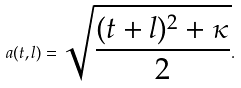<formula> <loc_0><loc_0><loc_500><loc_500>a ( t , l ) = \sqrt { \frac { ( t + l ) ^ { 2 } + \kappa } { 2 } } .</formula> 